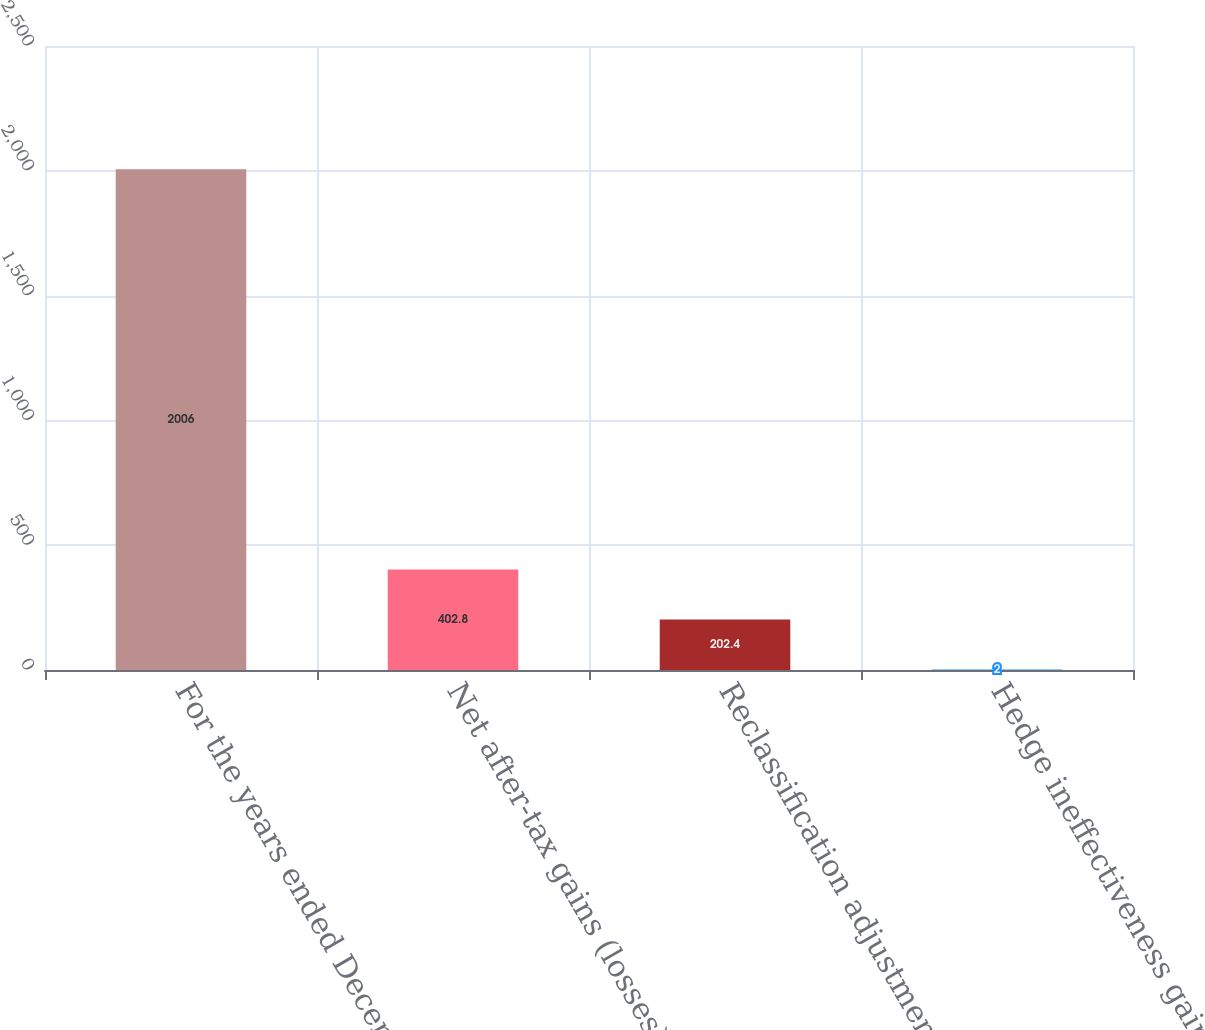Convert chart to OTSL. <chart><loc_0><loc_0><loc_500><loc_500><bar_chart><fcel>For the years ended December<fcel>Net after-tax gains (losses)<fcel>Reclassification adjustments<fcel>Hedge ineffectiveness gains<nl><fcel>2006<fcel>402.8<fcel>202.4<fcel>2<nl></chart> 